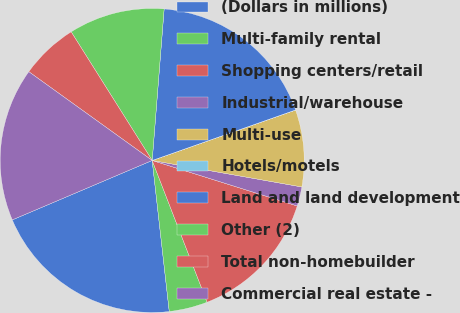<chart> <loc_0><loc_0><loc_500><loc_500><pie_chart><fcel>(Dollars in millions)<fcel>Multi-family rental<fcel>Shopping centers/retail<fcel>Industrial/warehouse<fcel>Multi-use<fcel>Hotels/motels<fcel>Land and land development<fcel>Other (2)<fcel>Total non-homebuilder<fcel>Commercial real estate -<nl><fcel>20.4%<fcel>4.09%<fcel>14.28%<fcel>2.05%<fcel>8.17%<fcel>0.01%<fcel>18.36%<fcel>10.2%<fcel>6.13%<fcel>16.32%<nl></chart> 